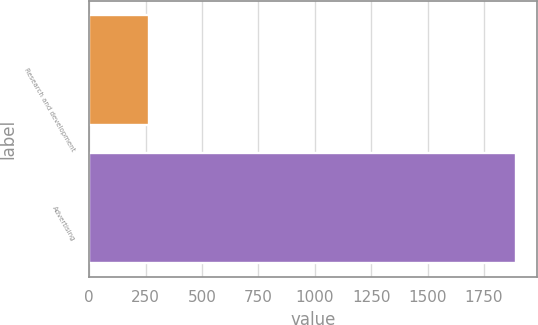<chart> <loc_0><loc_0><loc_500><loc_500><bar_chart><fcel>Research and development<fcel>Advertising<nl><fcel>267<fcel>1891<nl></chart> 